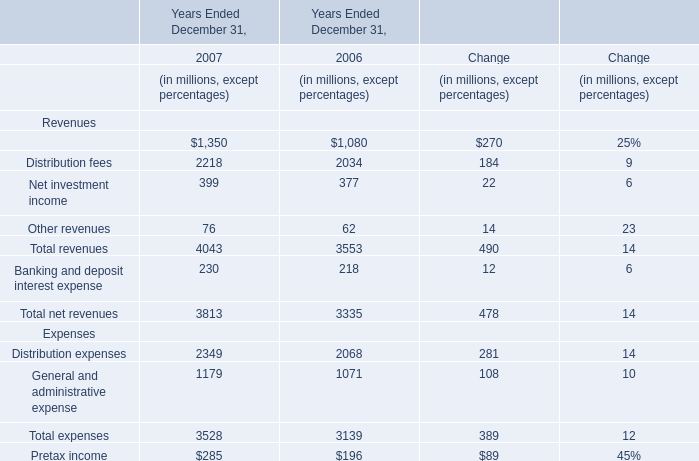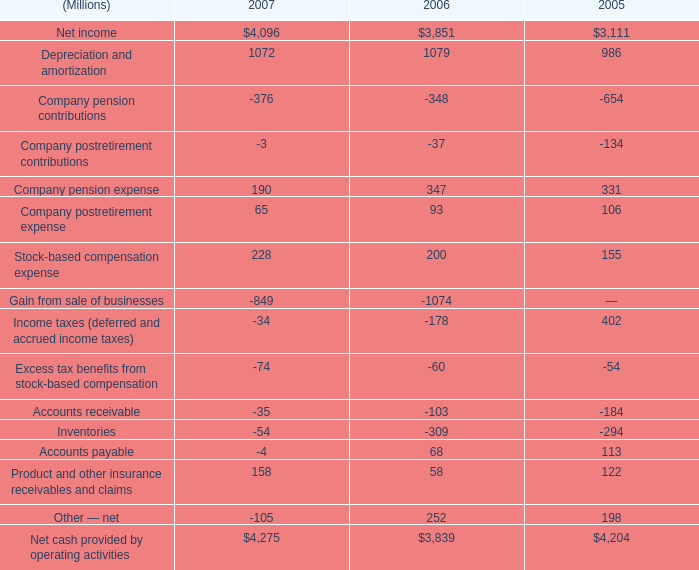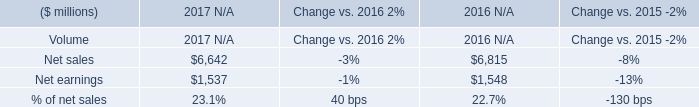What is the sum of Net cash provided by operating activities of 2007, and Net sales of 2017 N/A ? 
Computations: (4275.0 + 6642.0)
Answer: 10917.0. 